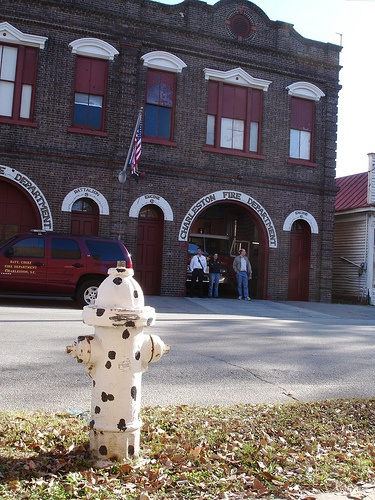Describe the objects in this image and their specific colors. I can see fire hydrant in black, tan, lightgray, and darkgray tones, car in black, maroon, navy, and purple tones, people in black, gray, navy, and darkblue tones, people in black, darkgray, purple, and gray tones, and people in black, navy, darkblue, and gray tones in this image. 